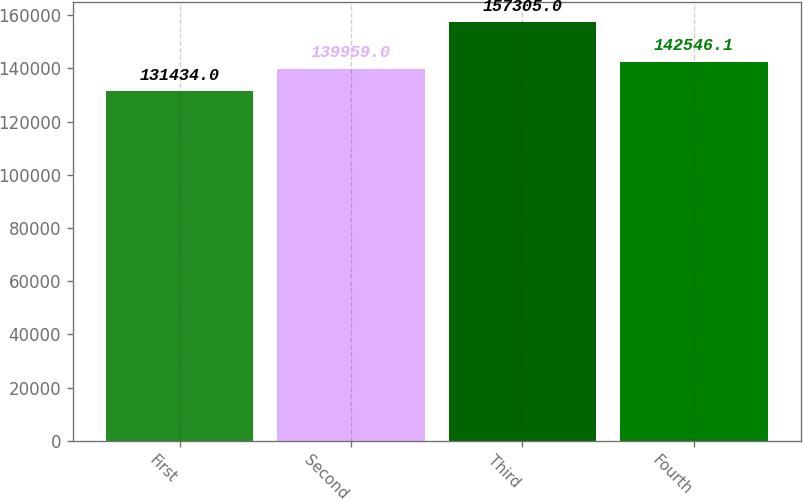Convert chart to OTSL. <chart><loc_0><loc_0><loc_500><loc_500><bar_chart><fcel>First<fcel>Second<fcel>Third<fcel>Fourth<nl><fcel>131434<fcel>139959<fcel>157305<fcel>142546<nl></chart> 